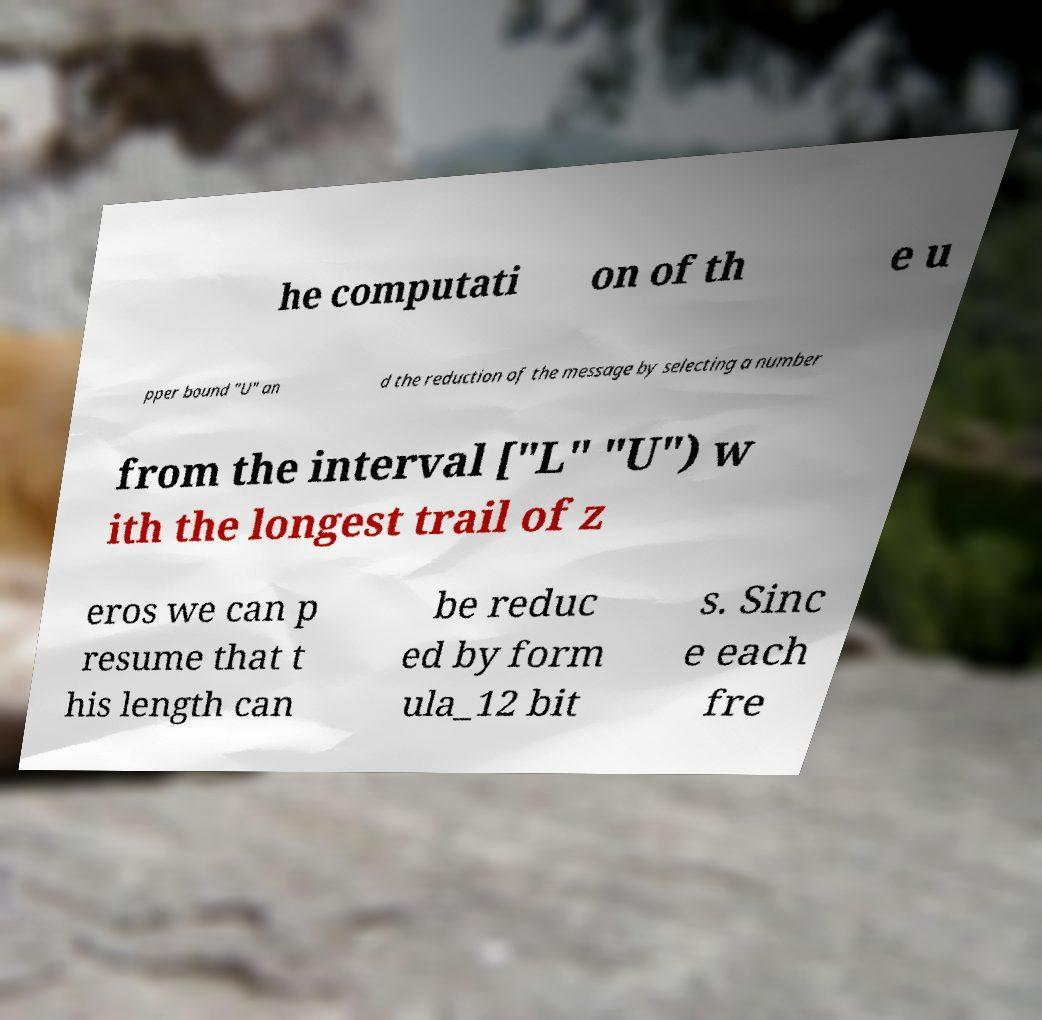I need the written content from this picture converted into text. Can you do that? he computati on of th e u pper bound "U" an d the reduction of the message by selecting a number from the interval ["L" "U") w ith the longest trail of z eros we can p resume that t his length can be reduc ed by form ula_12 bit s. Sinc e each fre 